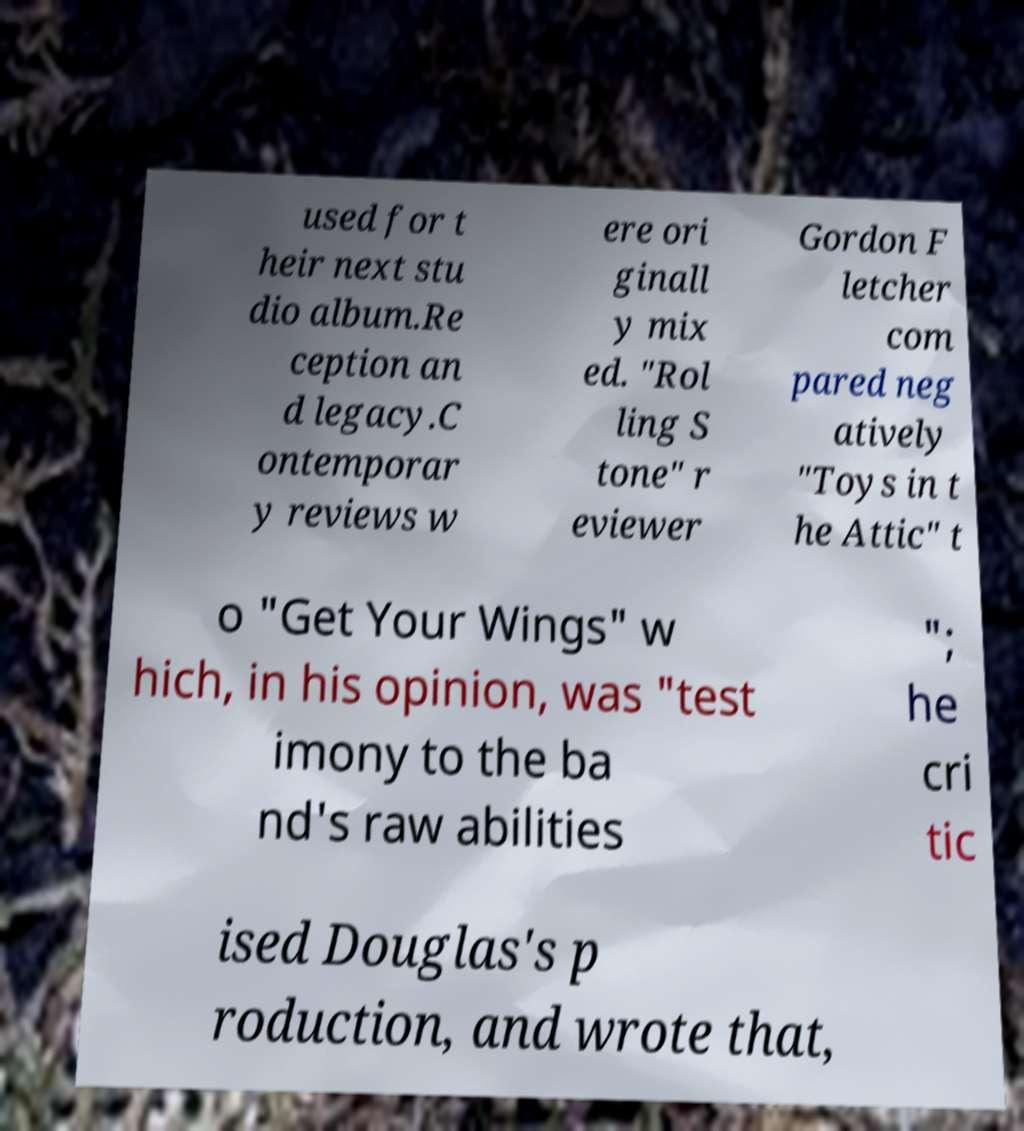Could you assist in decoding the text presented in this image and type it out clearly? used for t heir next stu dio album.Re ception an d legacy.C ontemporar y reviews w ere ori ginall y mix ed. "Rol ling S tone" r eviewer Gordon F letcher com pared neg atively "Toys in t he Attic" t o "Get Your Wings" w hich, in his opinion, was "test imony to the ba nd's raw abilities "; he cri tic ised Douglas's p roduction, and wrote that, 